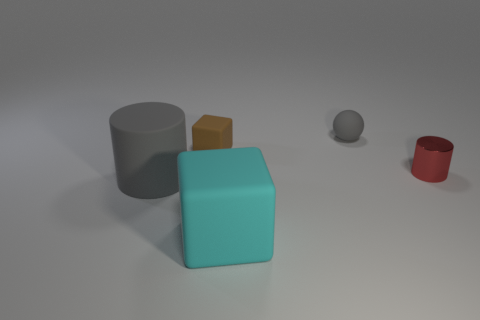How would you describe the size relationships between these objects? The teal cube is the largest, followed by the gray cylinder. The red cylinder is smaller in height compared to the gray one, and the yellow cube is the smallest object in the scene. 